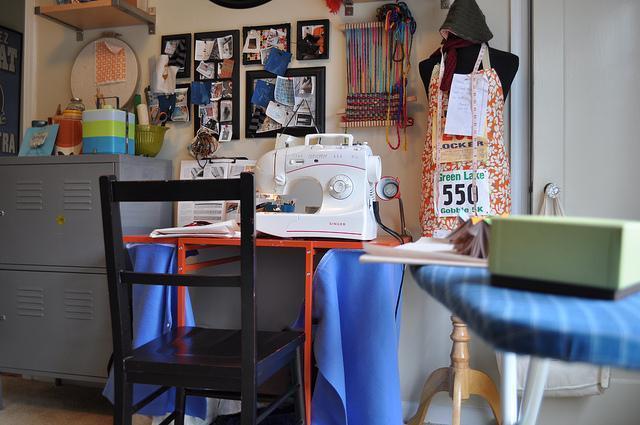How many people are standing on the floor?
Give a very brief answer. 0. 